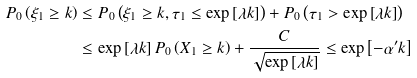<formula> <loc_0><loc_0><loc_500><loc_500>P _ { 0 } \left ( \xi _ { 1 } \geq k \right ) & \leq P _ { 0 } \left ( \xi _ { 1 } \geq k , \tau _ { 1 } \leq \exp \left [ \lambda k \right ] \right ) + P _ { 0 } \left ( \tau _ { 1 } > \exp \left [ \lambda k \right ] \right ) \\ & \leq \exp \left [ \lambda k \right ] P _ { 0 } \left ( X _ { 1 } \geq k \right ) + \frac { C } { \sqrt { \exp \left [ \lambda k \right ] } } \leq \exp \left [ - \alpha ^ { \prime } k \right ]</formula> 